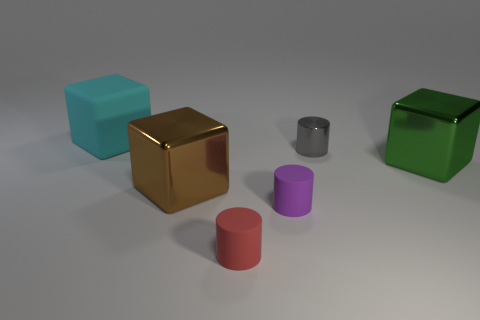How do the sizes of the objects compare to each other? In the image, we see a variety of sizes. The large cyan and green cubes appear to be the biggest objects, while the silver cylinder is mid-sized, and the purple and red cylinders look to be the smallest items, offering a visual array of proportions. 